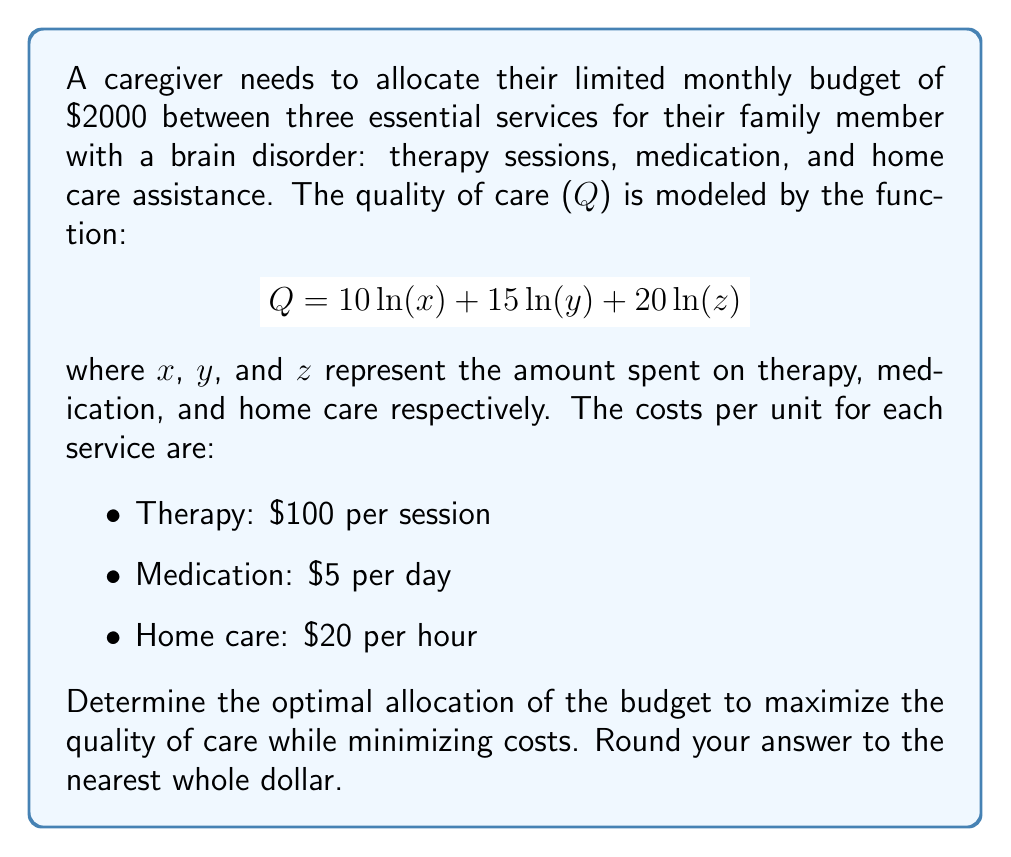Could you help me with this problem? To solve this optimization problem, we'll use the method of Lagrange multipliers.

Step 1: Set up the constraint equation.
$$x + 5y + 20z = 2000$$ (monthly budget constraint)

Step 2: Form the Lagrangian function.
$$L(x,y,z,\lambda) = 10\ln(x) + 15\ln(y) + 20\ln(z) - \lambda(x + 5y + 20z - 2000)$$

Step 3: Take partial derivatives and set them equal to zero.
$$\frac{\partial L}{\partial x} = \frac{10}{x} - \lambda = 0$$
$$\frac{\partial L}{\partial y} = \frac{15}{y} - 5\lambda = 0$$
$$\frac{\partial L}{\partial z} = \frac{20}{z} - 20\lambda = 0$$
$$\frac{\partial L}{\partial \lambda} = x + 5y + 20z - 2000 = 0$$

Step 4: Solve the system of equations.
From the first three equations:
$$x = \frac{10}{\lambda}, y = \frac{3}{\lambda}, z = \frac{1}{\lambda}$$

Substitute these into the constraint equation:
$$\frac{10}{\lambda} + 5\cdot\frac{3}{\lambda} + 20\cdot\frac{1}{\lambda} = 2000$$
$$\frac{45}{\lambda} = 2000$$
$$\lambda = \frac{45}{2000} = 0.0225$$

Step 5: Calculate the optimal values.
$$x = \frac{10}{0.0225} = 444.44$$
$$y = \frac{3}{0.0225} = 133.33$$
$$z = \frac{1}{0.0225} = 44.44$$

Step 6: Round to the nearest whole dollar.
x = $444, y = $133, z = $44

Step 7: Verify the budget constraint.
$444 + 5($133) + 20($44) = $2001 (slight rounding error)

Therefore, the optimal allocation is:
- Therapy: $444 (about 4 sessions per month)
- Medication: $133 (about 27 days worth)
- Home care: $44 (about 2 hours)
Answer: Therapy: $444, Medication: $133, Home care: $44 